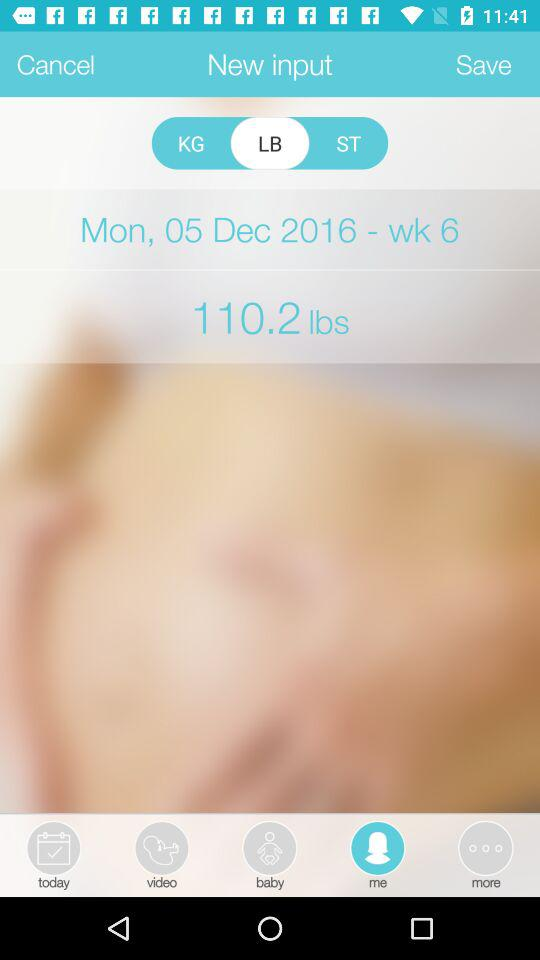What is the weight in lbs? The weight is 110.2 lbs. 